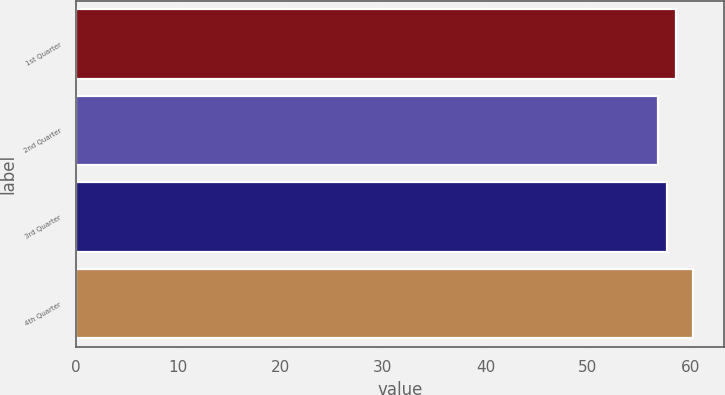<chart> <loc_0><loc_0><loc_500><loc_500><bar_chart><fcel>1st Quarter<fcel>2nd Quarter<fcel>3rd Quarter<fcel>4th Quarter<nl><fcel>58.65<fcel>56.86<fcel>57.71<fcel>60.3<nl></chart> 